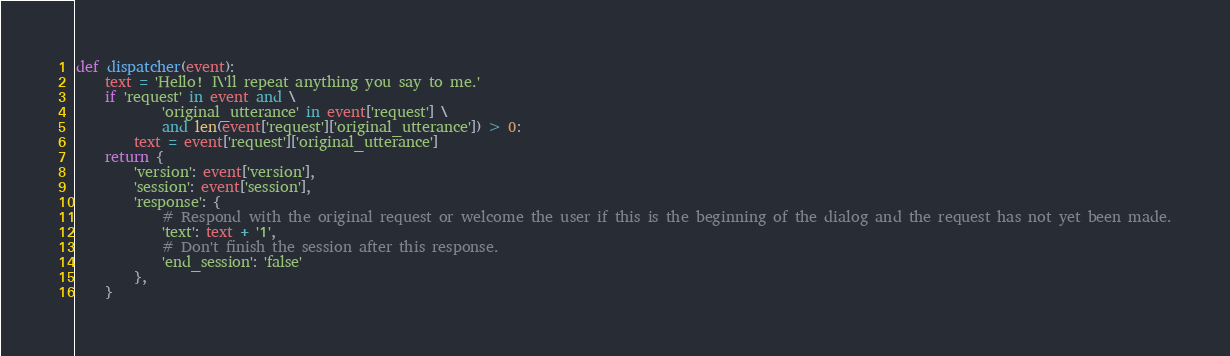Convert code to text. <code><loc_0><loc_0><loc_500><loc_500><_Python_>
def dispatcher(event):
    text = 'Hello! I\'ll repeat anything you say to me.'
    if 'request' in event and \
            'original_utterance' in event['request'] \
            and len(event['request']['original_utterance']) > 0:
        text = event['request']['original_utterance']
    return {
        'version': event['version'],
        'session': event['session'],
        'response': {
            # Respond with the original request or welcome the user if this is the beginning of the dialog and the request has not yet been made.
            'text': text + '1',
            # Don't finish the session after this response.
            'end_session': 'false'
        },
    }
</code> 